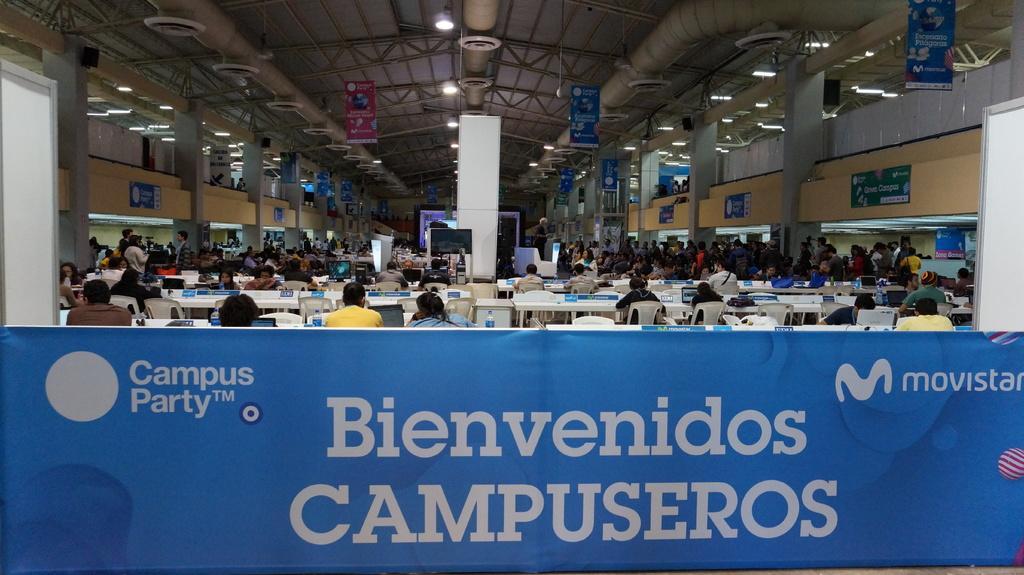Could you give a brief overview of what you see in this image? In this image I can see a group of people sitting on chairs. In front I can see systems,bags,and water bottles on the table. Back I can see few people standing and I can see boards,screens,pillars and lights. In front I can see a blue color board and something is written on it. 